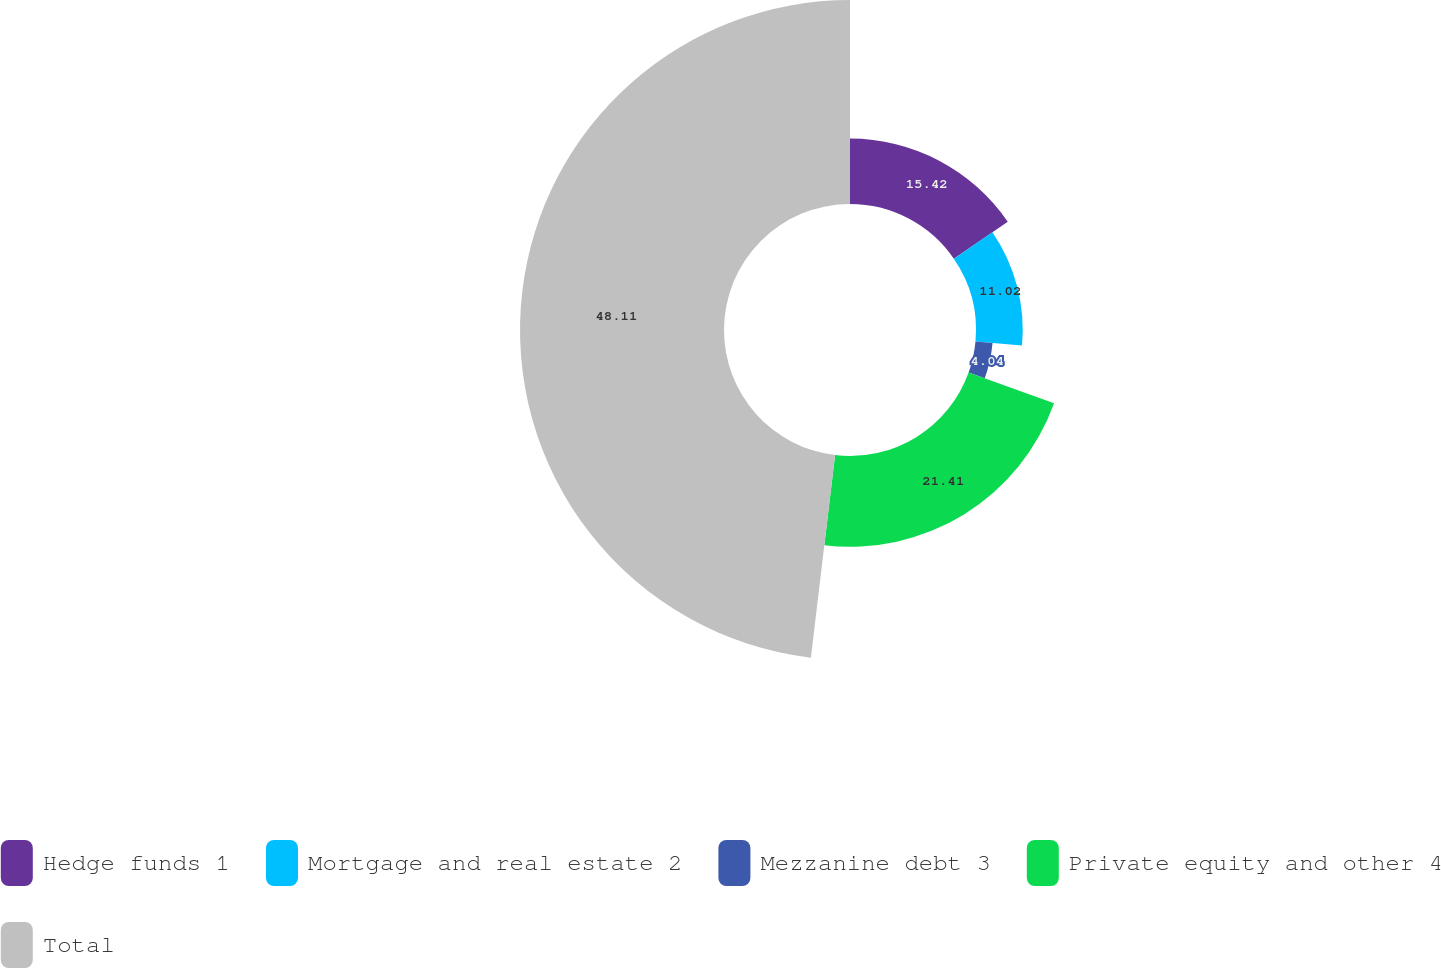Convert chart to OTSL. <chart><loc_0><loc_0><loc_500><loc_500><pie_chart><fcel>Hedge funds 1<fcel>Mortgage and real estate 2<fcel>Mezzanine debt 3<fcel>Private equity and other 4<fcel>Total<nl><fcel>15.42%<fcel>11.02%<fcel>4.04%<fcel>21.41%<fcel>48.11%<nl></chart> 